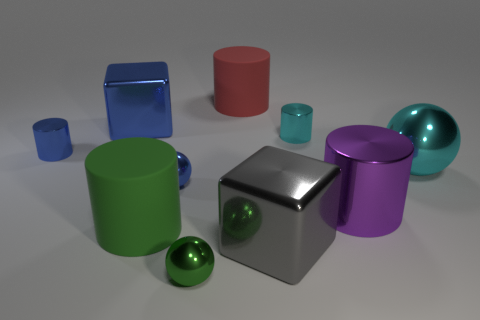Subtract all tiny blue metal cylinders. How many cylinders are left? 4 Subtract 2 cylinders. How many cylinders are left? 3 Subtract all cyan balls. How many balls are left? 2 Subtract all blocks. How many objects are left? 8 Subtract all purple cylinders. Subtract all blue blocks. How many cylinders are left? 4 Subtract all cyan balls. How many cyan cylinders are left? 1 Subtract all big blocks. Subtract all big green matte cylinders. How many objects are left? 7 Add 7 green balls. How many green balls are left? 8 Add 9 tiny blue metal cylinders. How many tiny blue metal cylinders exist? 10 Subtract 0 cyan blocks. How many objects are left? 10 